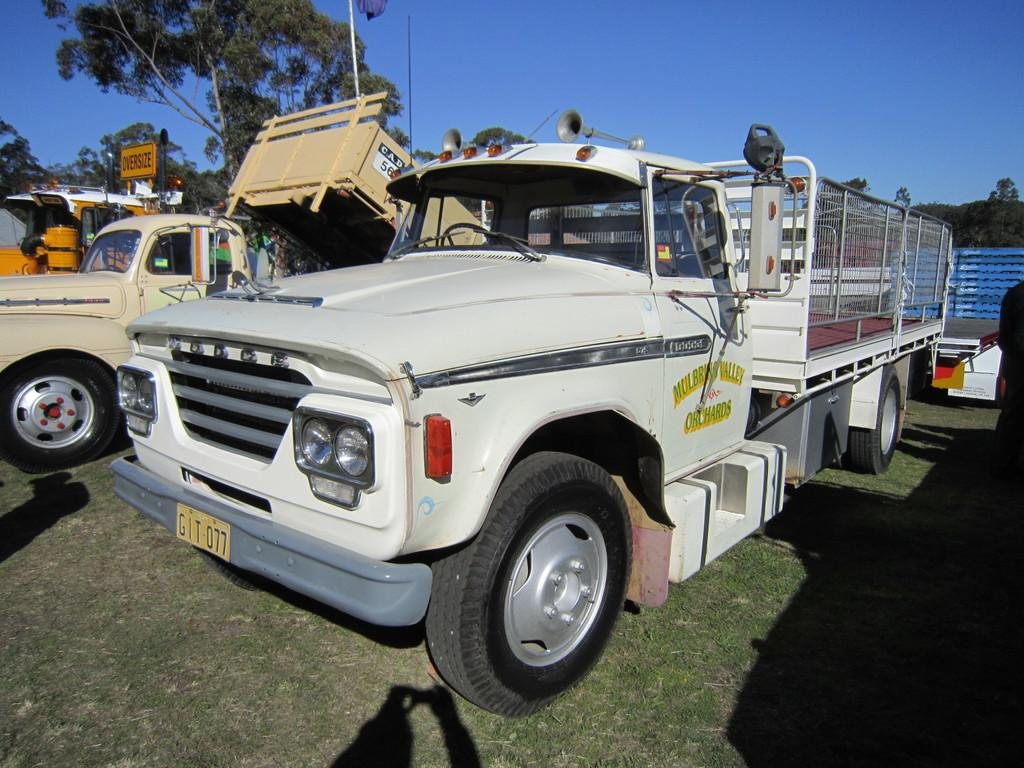What type of vehicles can be seen on the grassy land in the image? The image does not specify the type of vehicles, but there are vehicles present on the grassy land. What other elements can be seen in the image besides the vehicles? Trees are visible in the image. What is visible at the top of the image? The sky is visible at the top of the image. What type of plantation can be seen through the window in the image? There is no window present in the image, and therefore no plantation can be seen through it. 